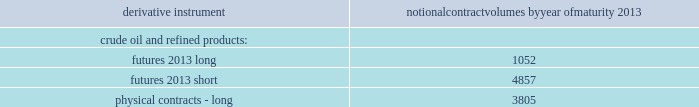Table of contents valero energy corporation and subsidiaries notes to consolidated financial statements ( continued ) commodity price risk we are exposed to market risks related to the volatility in the price of crude oil , refined products ( primarily gasoline and distillate ) , grain ( primarily corn ) , and natural gas used in our operations .
To reduce the impact of price volatility on our results of operations and cash flows , we use commodity derivative instruments , including futures , swaps , and options .
We use the futures markets for the available liquidity , which provides greater flexibility in transacting our hedging and trading operations .
We use swaps primarily to manage our price exposure .
Our positions in commodity derivative instruments are monitored and managed on a daily basis by a risk control group to ensure compliance with our stated risk management policy that has been approved by our board of directors .
For risk management purposes , we use fair value hedges , cash flow hedges , and economic hedges .
In addition to the use of derivative instruments to manage commodity price risk , we also enter into certain commodity derivative instruments for trading purposes .
Our objective for entering into each type of hedge or trading derivative is described below .
Fair value hedges fair value hedges are used to hedge price volatility in certain refining inventories and firm commitments to purchase inventories .
The level of activity for our fair value hedges is based on the level of our operating inventories , and generally represents the amount by which our inventories differ from our previous year-end lifo inventory levels .
As of december 31 , 2012 , we had the following outstanding commodity derivative instruments that were entered into to hedge crude oil and refined product inventories and commodity derivative instruments related to the physical purchase of crude oil and refined products at a fixed price .
The information presents the notional volume of outstanding contracts by type of instrument and year of maturity ( volumes in thousands of barrels ) .
Notional contract volumes by year of maturity derivative instrument 2013 .

What percentage increase would in long futures would need to occur to double the short futures? 
Computations: ((((4857 * 2) - 3805) - 1052) / 1052)
Answer: 4.61692. 